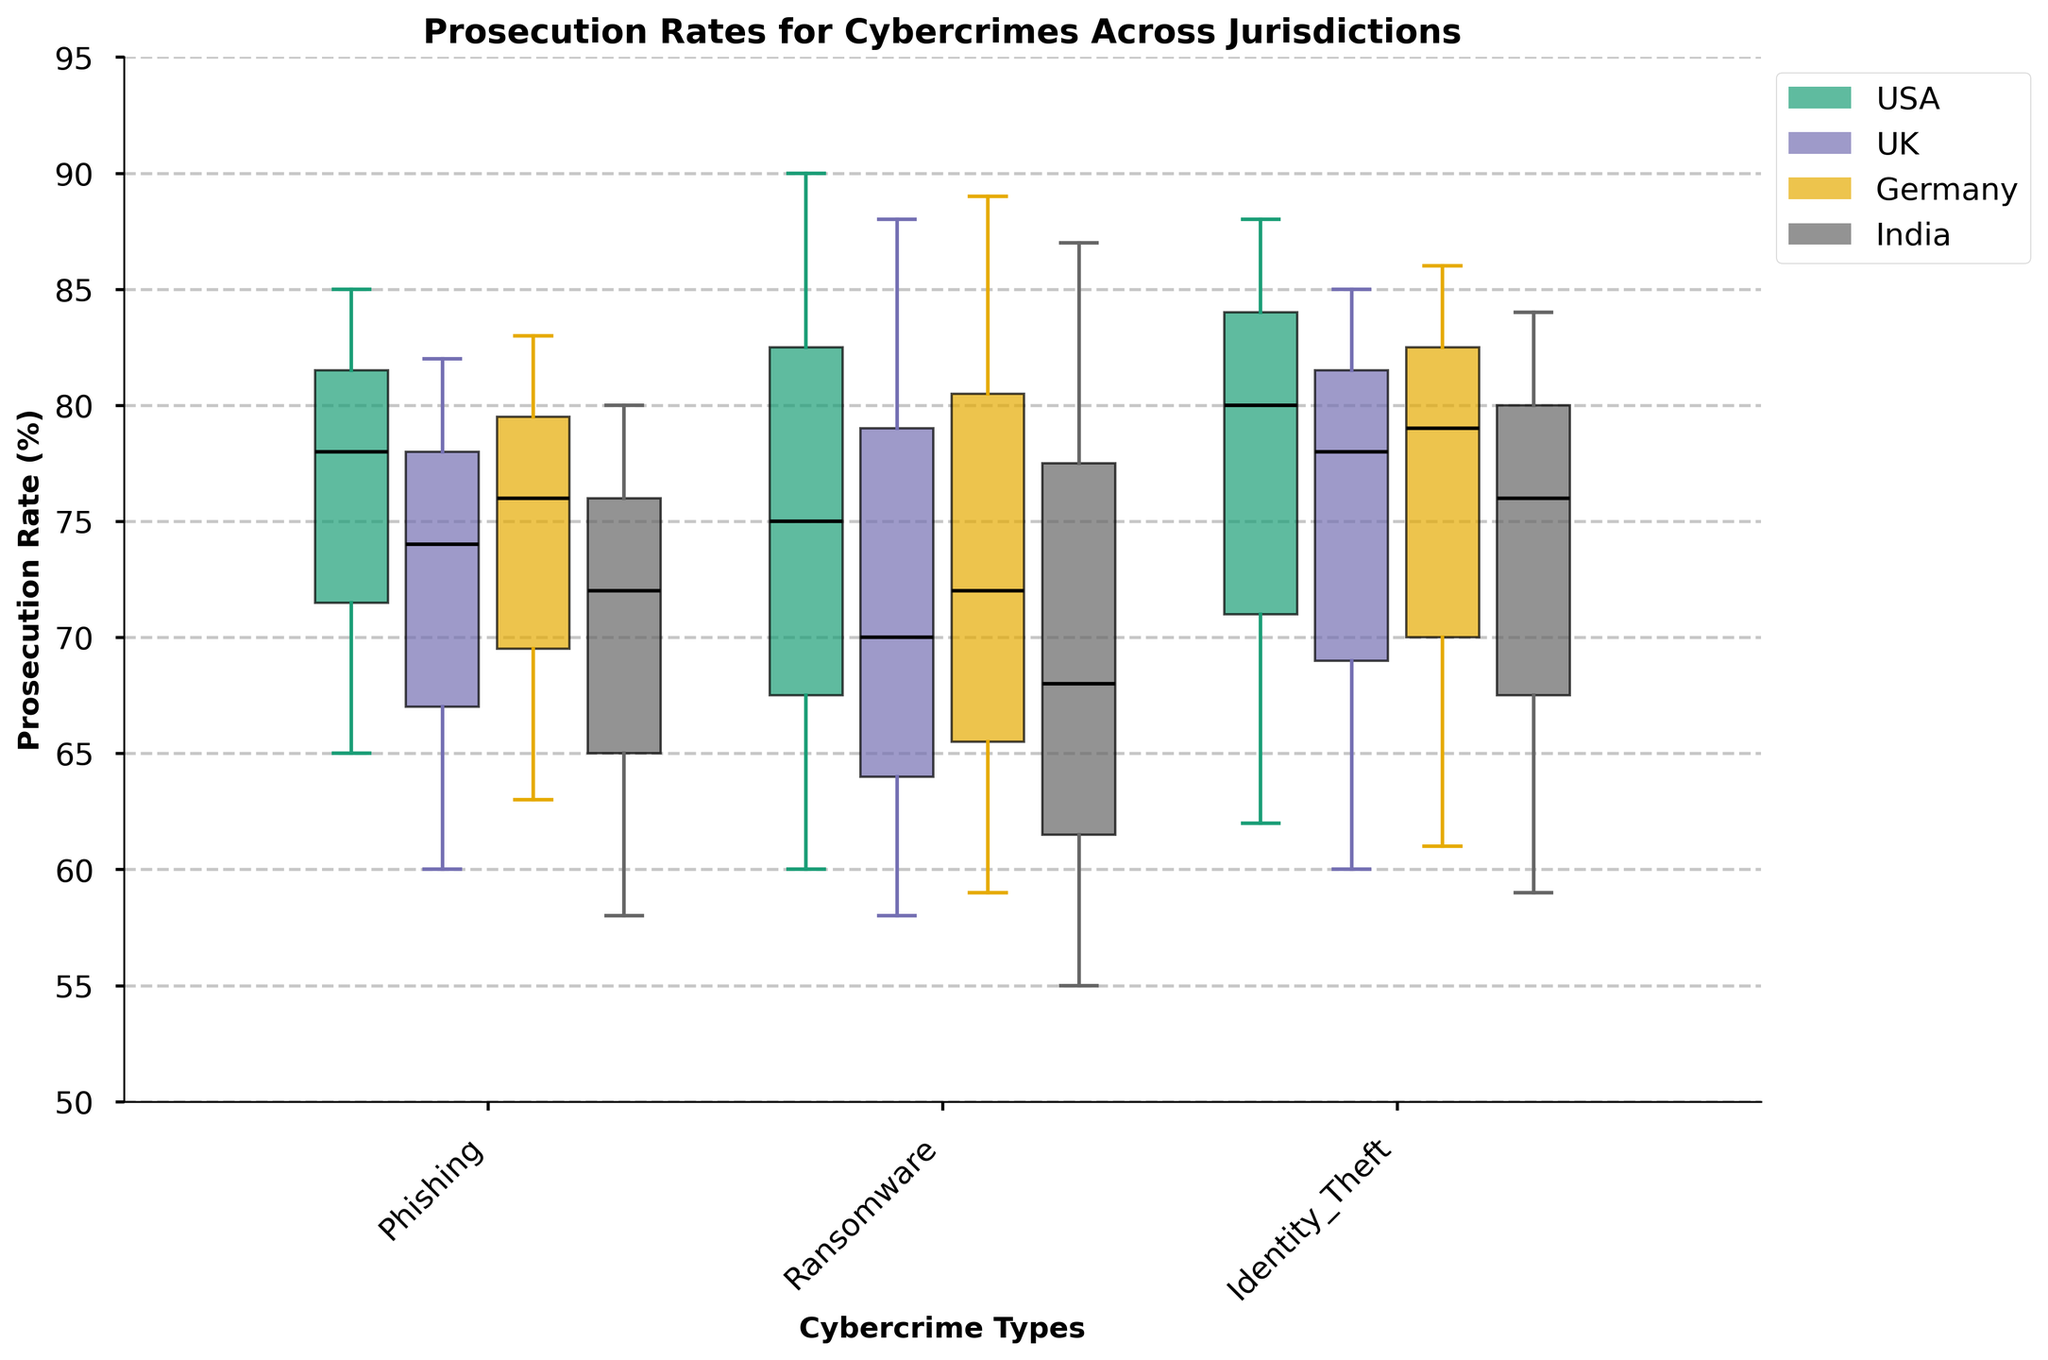What's the title of the plot? The title is displayed at the top of the plot and is meant to summarize the content being shown. Here it reads "Prosecution Rates for Cybercrimes Across Jurisdictions".
Answer: Prosecution Rates for Cybercrimes Across Jurisdictions Which jurisdiction has the highest median prosecution rate for Identity Theft cases of low complexity? Look for the box plot corresponding to Identity Theft under Low complexity and identify the jurisdiction (color-coded) with the highest median line on the y-axis. The highest median prosecution rate is shown by the USA.
Answer: USA For Phishing cases, which jurisdiction shows the highest variability (i.e., range between whiskers) at high complexity? Check the box plots for Phishing under High complexity. The whiskers define the range. UK has the largest range, indicating the highest variability.
Answer: UK What are the y-axis limits in the plot? The y-axis limits are the minimum and maximum values shown on the y-axis. Here, they are set from 50 to 95.
Answer: 50 to 95 Which crime type has the lowest median prosecution rate in Germany? Look at the median lines in the box plots for Germany. Compare them across all crime types. Phishing at high complexity has the lowest median prosecution rate in Germany.
Answer: Phishing (High complexity) How does the median prosecution rate for Ransomware cases of high complexity compare between the USA and India? Find the Ransomware box plots under High complexity for both the USA and India. Compare the median lines of these two plots. The USA's median is higher than India's.
Answer: The median is higher in the USA Which crime type shows the smallest difference in median prosecution rates between low and high complexity cases in the UK? For each crime type in the UK, subtract the median value of high complexity from the median value of low complexity cases. The smallest difference is seen in Identity Theft.
Answer: Identity Theft Among all jurisdictions, which one has the most consistent prosecution rates (i.e., smallest interquartile range) for Ransomware cases across all complexities? Look for the box plots for Ransomware across all complexities and identify the jurisdiction with the smallest interquartile range (distance between the top and bottom of the box). Germany shows the most consistent prosecution rates.
Answer: Germany Does any jurisdiction achieve a 90% prosecution rate for any crime type at any complexity level? Check the top of the each box or whisker for each crime type, complexity, and jurisdiction. In the USA, Ransomware at low complexity reaches a 90% prosecution rate.
Answer: Yes, in the USA for Ransomware at low complexity 